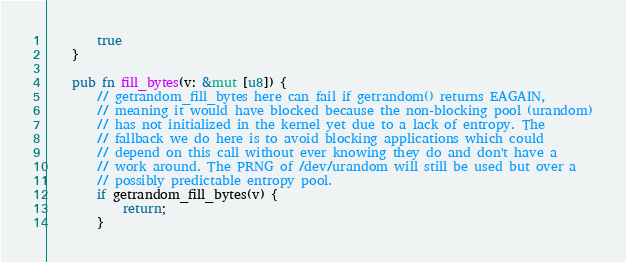Convert code to text. <code><loc_0><loc_0><loc_500><loc_500><_Rust_>        true
    }

    pub fn fill_bytes(v: &mut [u8]) {
        // getrandom_fill_bytes here can fail if getrandom() returns EAGAIN,
        // meaning it would have blocked because the non-blocking pool (urandom)
        // has not initialized in the kernel yet due to a lack of entropy. The
        // fallback we do here is to avoid blocking applications which could
        // depend on this call without ever knowing they do and don't have a
        // work around. The PRNG of /dev/urandom will still be used but over a
        // possibly predictable entropy pool.
        if getrandom_fill_bytes(v) {
            return;
        }
</code> 